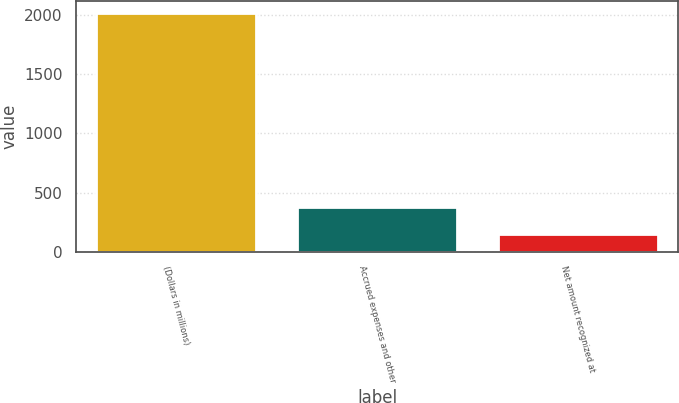Convert chart to OTSL. <chart><loc_0><loc_0><loc_500><loc_500><bar_chart><fcel>(Dollars in millions)<fcel>Accrued expenses and other<fcel>Net amount recognized at<nl><fcel>2012<fcel>374<fcel>154<nl></chart> 